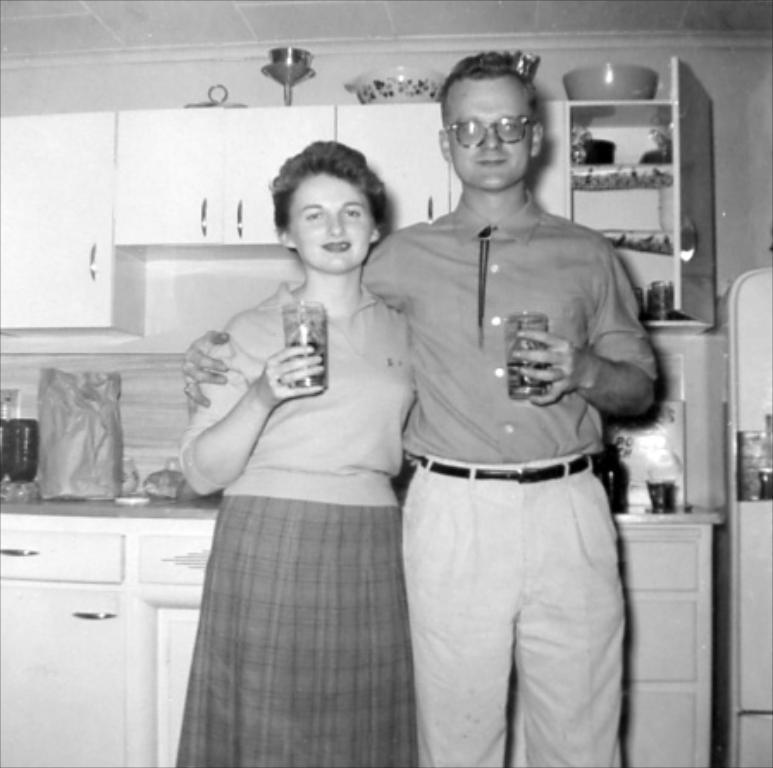What is the color scheme of the image? The image is black and white. What are the people in the image doing? The people in the image are holding objects. What can be seen on the wall in the image? There is a wall with cupboards in the image. What is inside the cupboards? There are objects inside the cupboards. What part of the building can be seen in the image? The roof is visible in the image. What type of metal is the crow using to open the cupboard in the image? There is no crow or metal present in the image. Who is the representative of the group in the image? The image does not depict a group or a representative. 